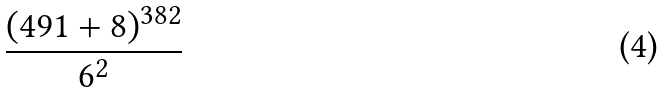<formula> <loc_0><loc_0><loc_500><loc_500>\frac { ( 4 9 1 + 8 ) ^ { 3 8 2 } } { 6 ^ { 2 } }</formula> 